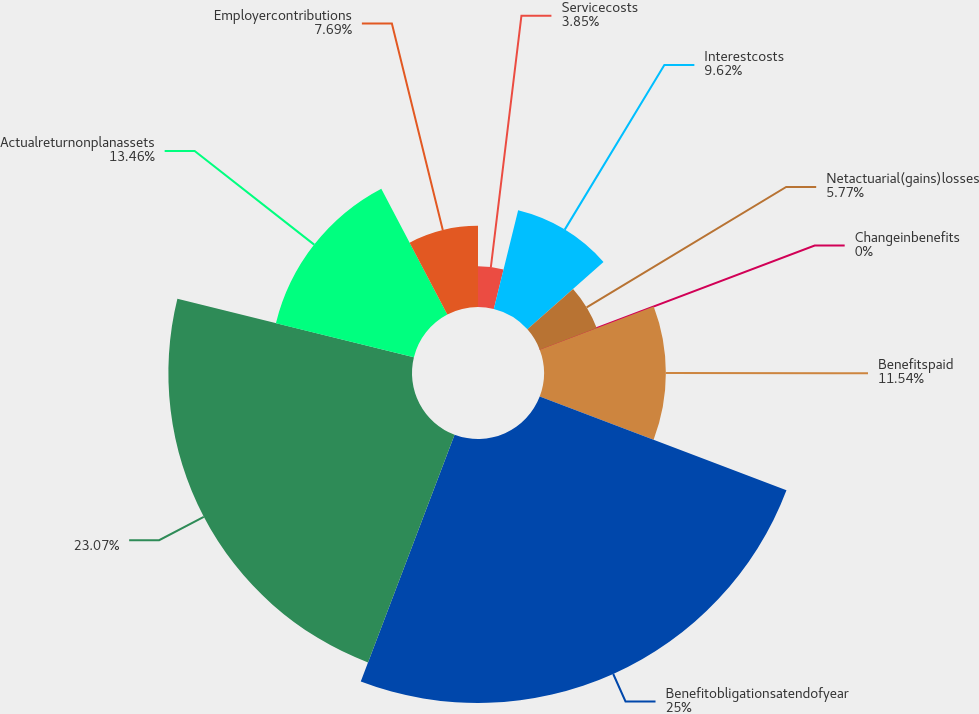Convert chart to OTSL. <chart><loc_0><loc_0><loc_500><loc_500><pie_chart><fcel>Servicecosts<fcel>Interestcosts<fcel>Netactuarial(gains)losses<fcel>Changeinbenefits<fcel>Benefitspaid<fcel>Benefitobligationsatendofyear<fcel>Unnamed: 6<fcel>Actualreturnonplanassets<fcel>Employercontributions<nl><fcel>3.85%<fcel>9.62%<fcel>5.77%<fcel>0.0%<fcel>11.54%<fcel>25.0%<fcel>23.07%<fcel>13.46%<fcel>7.69%<nl></chart> 